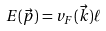Convert formula to latex. <formula><loc_0><loc_0><loc_500><loc_500>E ( \vec { p } ) = v _ { F } ( \vec { k } ) \ell</formula> 